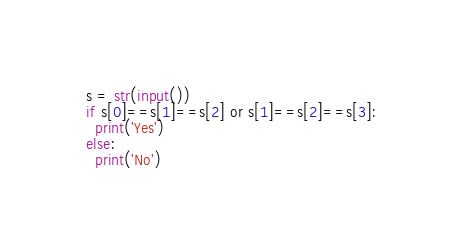Convert code to text. <code><loc_0><loc_0><loc_500><loc_500><_Python_>s = str(input())
if s[0]==s[1]==s[2] or s[1]==s[2]==s[3]:
  print('Yes')
else:
  print('No')</code> 